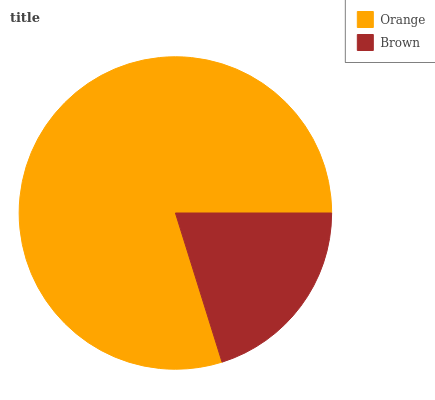Is Brown the minimum?
Answer yes or no. Yes. Is Orange the maximum?
Answer yes or no. Yes. Is Brown the maximum?
Answer yes or no. No. Is Orange greater than Brown?
Answer yes or no. Yes. Is Brown less than Orange?
Answer yes or no. Yes. Is Brown greater than Orange?
Answer yes or no. No. Is Orange less than Brown?
Answer yes or no. No. Is Orange the high median?
Answer yes or no. Yes. Is Brown the low median?
Answer yes or no. Yes. Is Brown the high median?
Answer yes or no. No. Is Orange the low median?
Answer yes or no. No. 